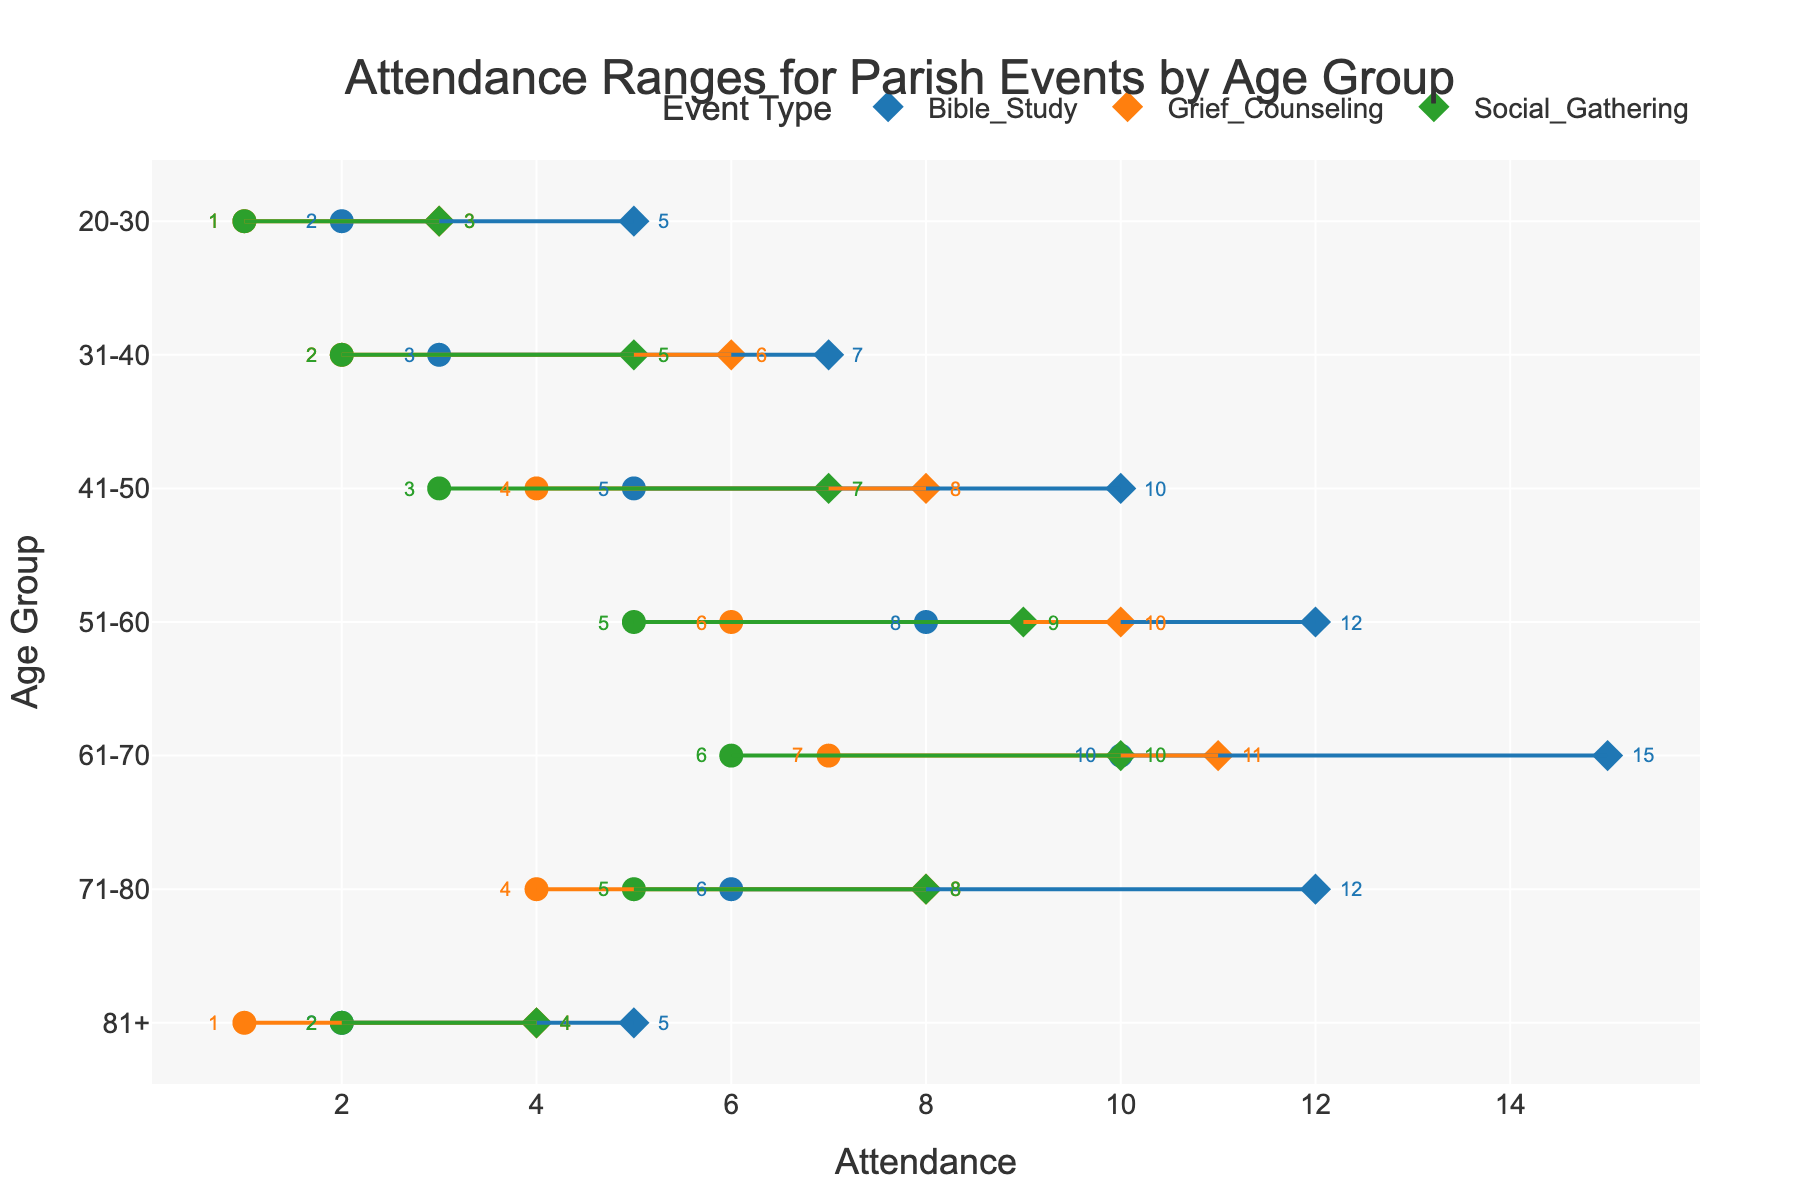How is the attendance for Social Gathering events among the 31-40 age group different from Bible Study events in the same age group? The figure shows that Social Gatherings have a minimum attendance of 2 and a maximum of 5 for the 31-40 age group, while Bible Study events have a minimum attendance of 3 and a maximum of 7 for the same age group. Thus, both the minimum and maximum attendance for Bible Study are higher than those for Social Gatherings in this age group.
Answer: Bible Study has higher attendance Which event has the highest maximum attendance among the 61-70 age group? By examining the dotted lines and markings in the figure, we observe that Bible Study shows a maximum attendance of 15, Grief Counseling shows a maximum of 11, and Social Gathering shows a maximum of 10 in the 61-70 age group.
Answer: Bible Study How does the maximum attendance range for Bible Study change across different age groups? For Bible Study, the maximum attendance changes as follows: 20-30 (5), 31-40 (7), 41-50 (10), 51-60 (12), 61-70 (15), 71-80 (12), 81+ (5). The attendance generally increases with age up to the 61-70 age group, then slightly decreases.
Answer: Generally increases up to 61-70, then decreases Is there any age group where Grief Counseling's minimum attendance is higher than Bible Study's minimum attendance? By comparing each age group, Bible Study's minimum attendance is never less than that of Grief Counseling. In each case, Bible Study has equal or higher minimum attendances.
Answer: No What is the range of attendance for the 51-60 age group for Social Gatherings? The figure shows that Social Gatherings for the 51-60 age group have a minimum attendance of 5 and a maximum attendance of 9. The range can be calculated as 9 - 5.
Answer: 4 How does the attendance trend for Bible Study differ from Grief Counseling in the 71-80 age group? In the 71-80 age group, Bible Study has a minimum attendance of 6 and a maximum of 12, while Grief Counseling has a minimum attendance of 4 and a maximum of 8. Both the minimum and maximum attendances for Bible Study are higher compared to Grief Counseling in this age group.
Answer: Bible Study has higher attendance Between Bible Study and Social Gathering for the 81+ age group, which one has a narrower attendance range? For the 81+ age group, Bible Study shows a range with a minimum of 2 and a maximum of 5 (range = 3), while Social Gathering shows a range with a minimum of 2 and a maximum of 4 (range = 2).
Answer: Social Gathering 